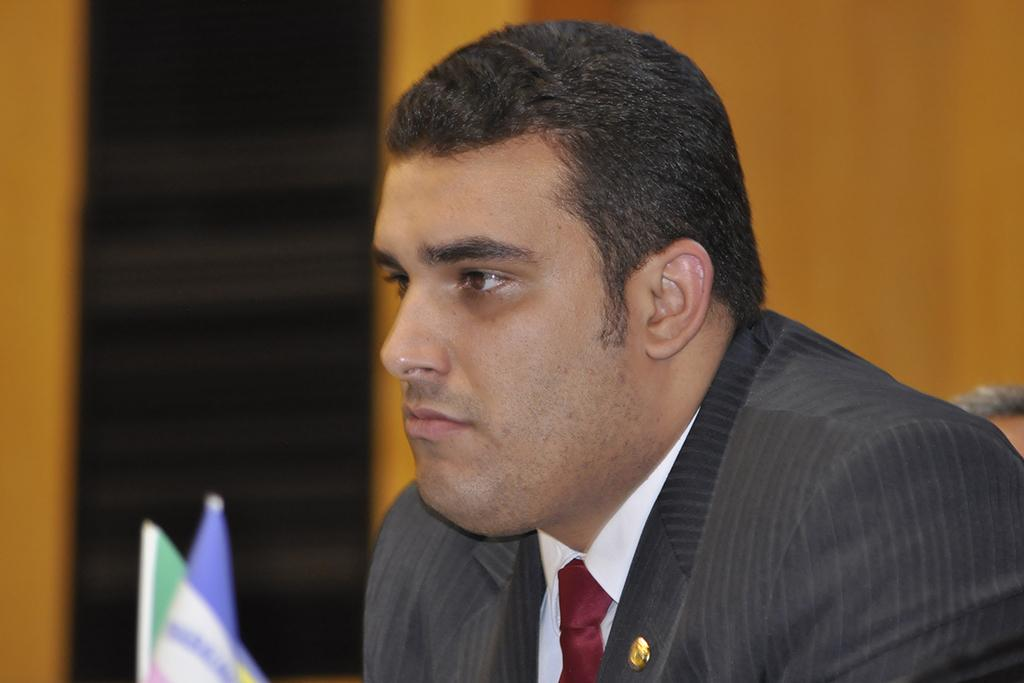Who is present in the image? There is a man in the image. What is the man wearing? The man is wearing a suit. What can be seen on the left side of the image? There is a flag on the left side of the image. Can you describe the background of the image? The background of the image is blurry. What type of songs is the man singing in the image? There is no indication in the image that the man is singing any songs, so it cannot be determined from the picture. 